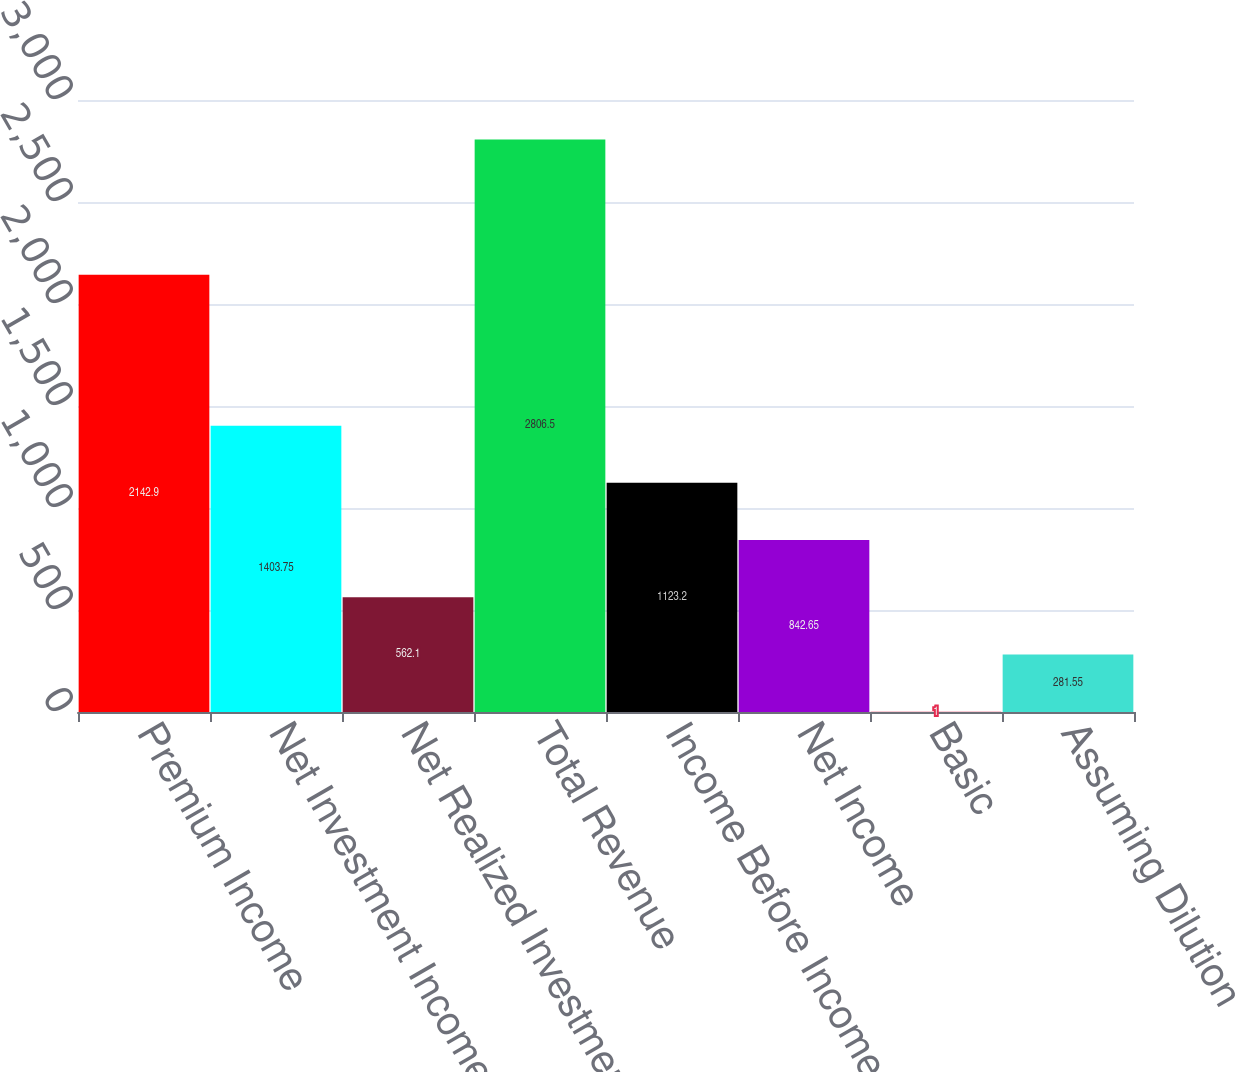<chart> <loc_0><loc_0><loc_500><loc_500><bar_chart><fcel>Premium Income<fcel>Net Investment Income<fcel>Net Realized Investment Gain<fcel>Total Revenue<fcel>Income Before Income Tax<fcel>Net Income<fcel>Basic<fcel>Assuming Dilution<nl><fcel>2142.9<fcel>1403.75<fcel>562.1<fcel>2806.5<fcel>1123.2<fcel>842.65<fcel>1<fcel>281.55<nl></chart> 